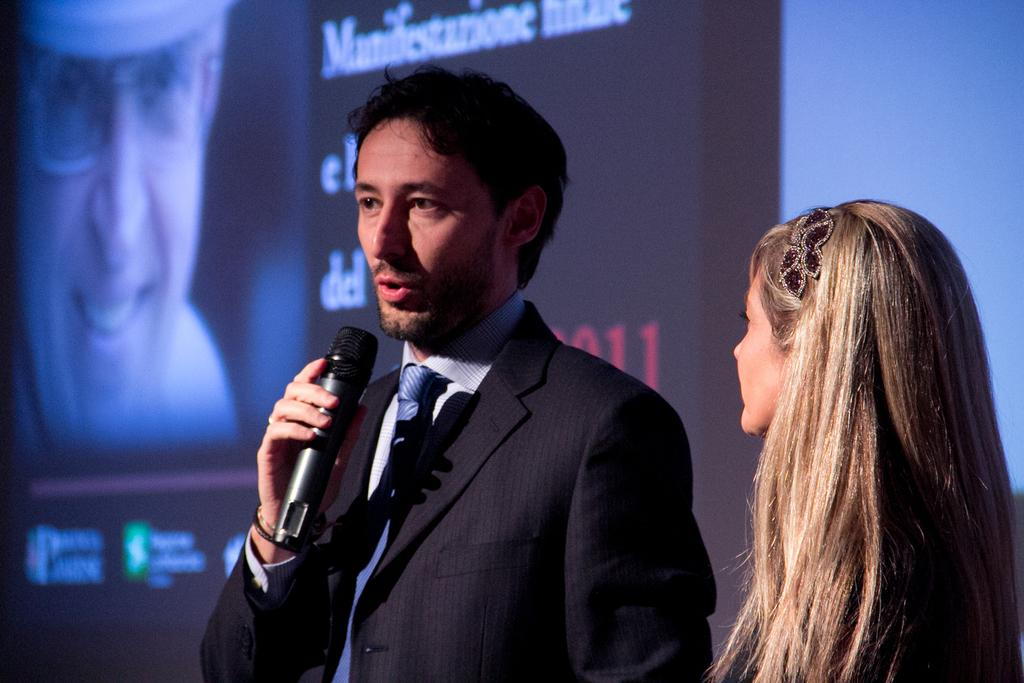Who are the people in the image? There is a man and a woman standing in the image. What is the man doing in the image? The man is speaking with the help of a microphone. What else can be seen in the background of the image? There is a hoarding visible in the image. What type of nerve is being treated by the doctor in the image? There is no doctor or mention of nerves in the image; it features a man speaking with a microphone and a woman standing nearby. 